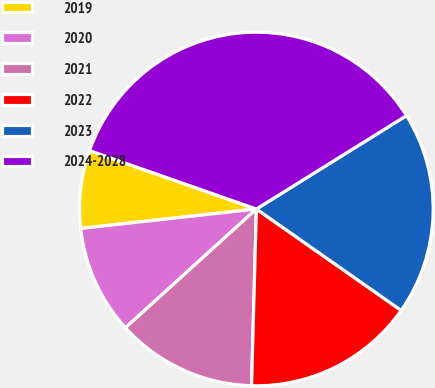Convert chart to OTSL. <chart><loc_0><loc_0><loc_500><loc_500><pie_chart><fcel>2019<fcel>2020<fcel>2021<fcel>2022<fcel>2023<fcel>2024-2028<nl><fcel>7.11%<fcel>9.97%<fcel>12.84%<fcel>15.71%<fcel>18.58%<fcel>35.79%<nl></chart> 